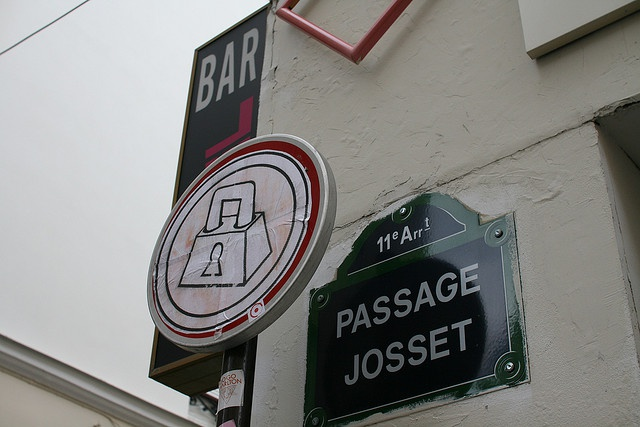Describe the objects in this image and their specific colors. I can see various objects in this image with different colors. 